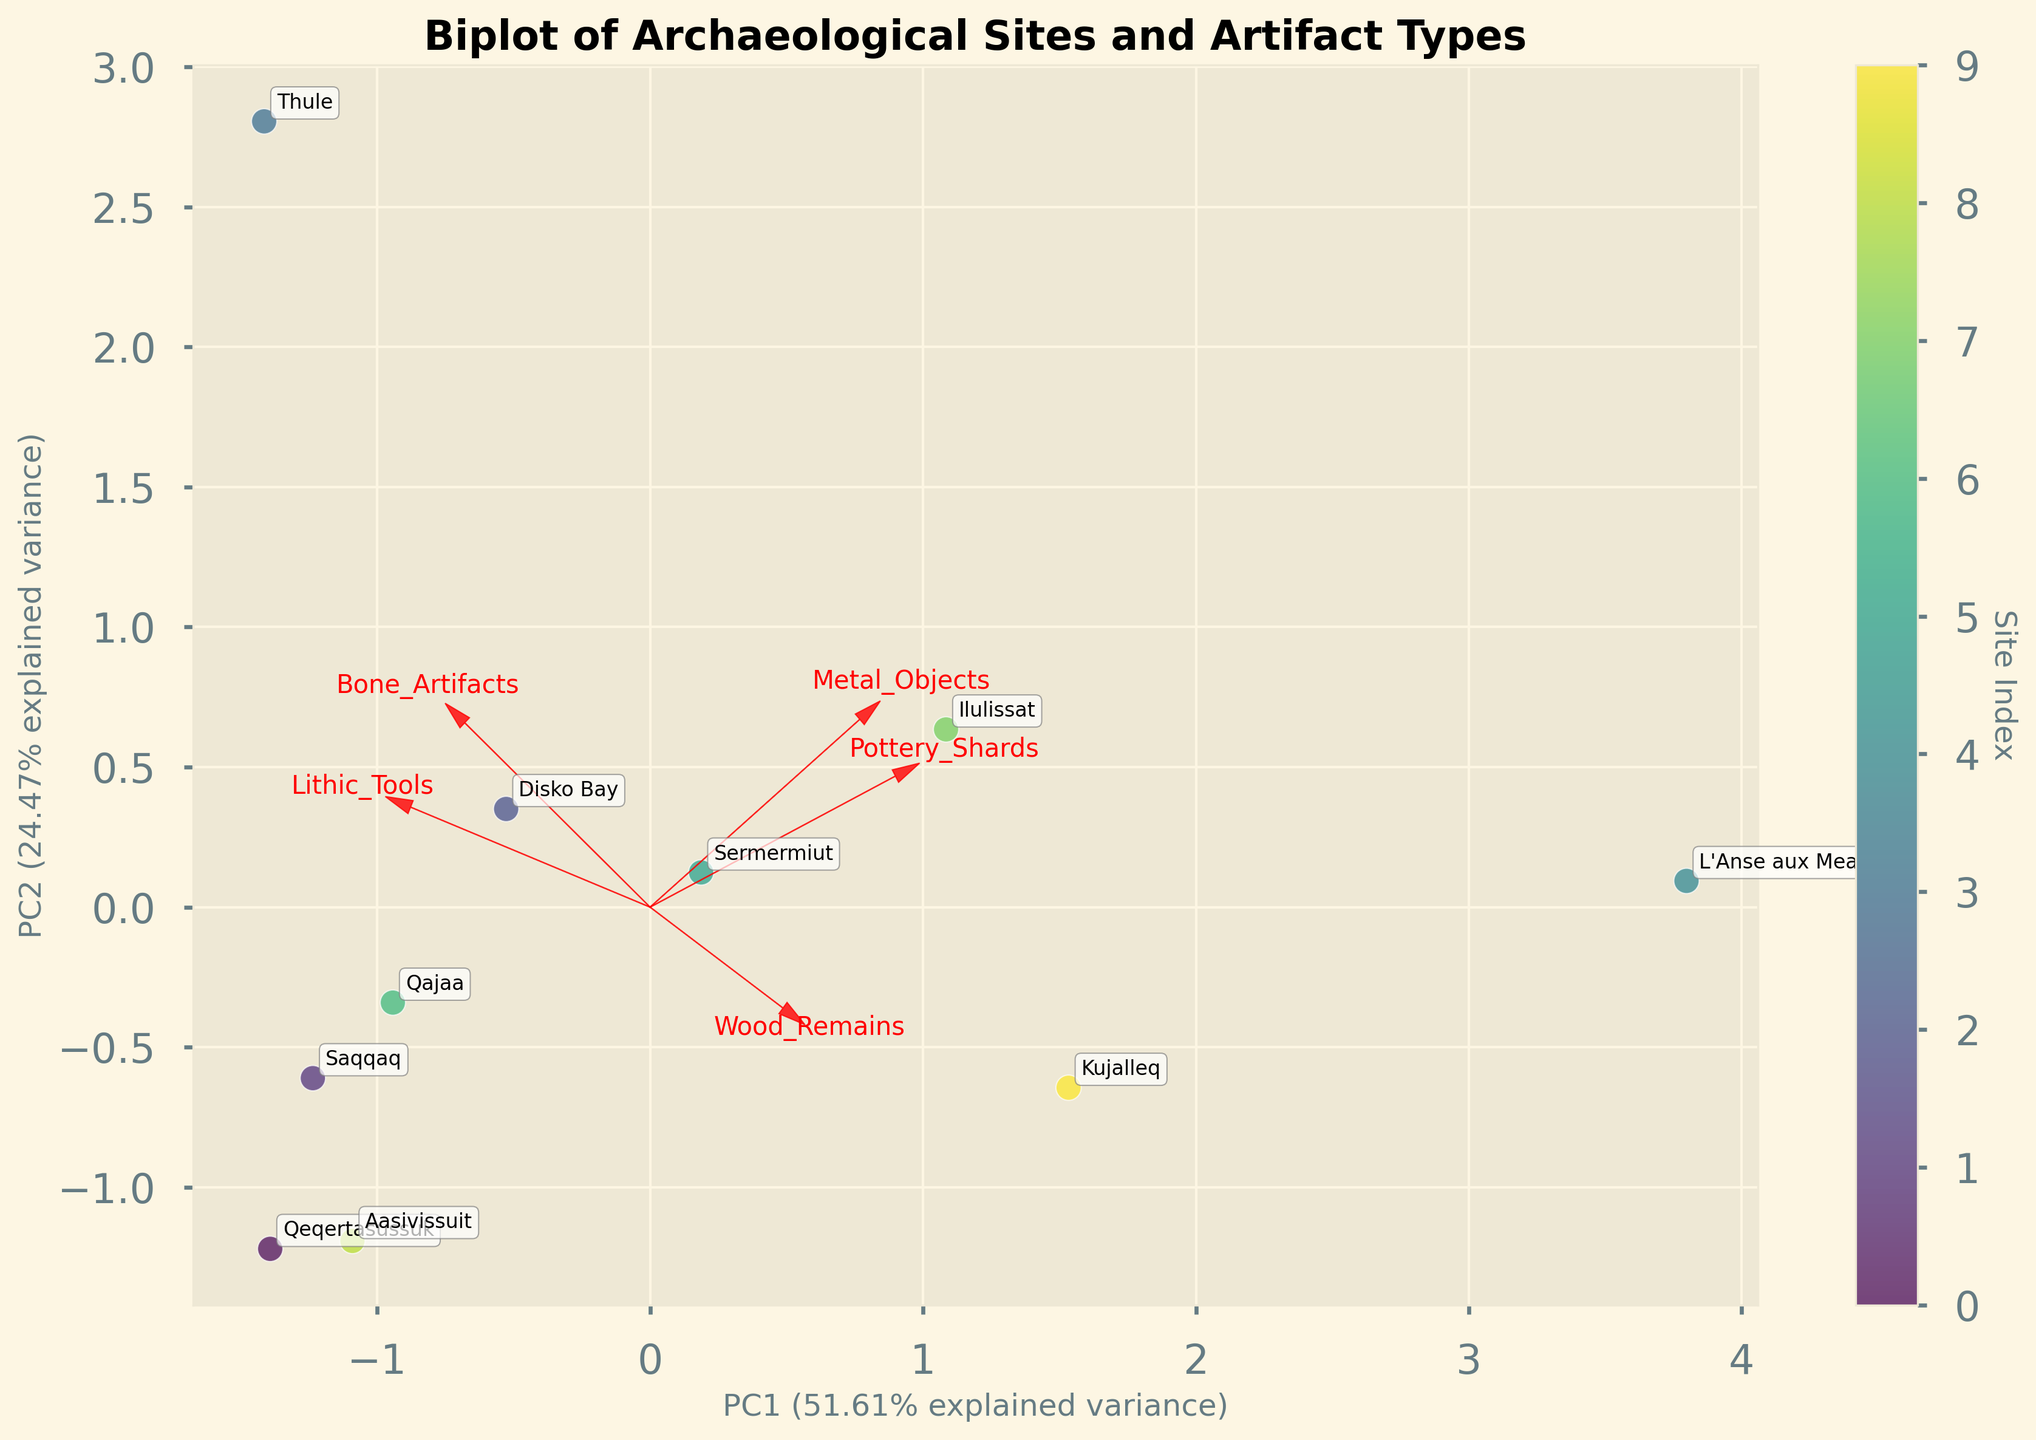What is the title of the figure? The title is usually found at the top of the figure in larger and bolder font to indicate the subject of the plot.
Answer: Biplot of Archaeological Sites and Artifact Types Which site has the highest value on the PC1 axis? To find the site with the highest value on the PC1 axis, look for the data point that is farthest to the right on the horizontal axis.
Answer: Thule How many archaeological sites are represented in the biplot? Count the number of unique labels or annotations in the plot to determine the number of archaeological sites represented.
Answer: 10 Which artifact type has the strongest positive influence on the first principal component (PC1)? Identify the loading vectors (red arrows) and see which artifact type's vector points most strongly in the positive direction of the PC1 axis.
Answer: Bone Artifacts Which two sites appear to be the most similar based on their positions in the biplot? Look for two data points that are closest to each other on the plot, indicating they have similar PC1 and PC2 scores.
Answer: Saqqaq and Qeqertasussuk What is the approximate explained variance of PC1? Check the label of the PC1 axis, which indicates the percentage of the total variance explained by the first principal component.
Answer: Approximately 54% Which artifact types have a negative influence on the second principal component (PC2)? Identify the loading vectors that point downward, indicating a negative influence on the PC2 axis, and then check the labels of these vectors.
Answer: Wood Remains and Metal Objects Which site is positioned furthest in the positive direction along the PC2 axis? Look at the vertical axis (PC2) and find the data point that is highest up, indicating the furthest positive value along this axis.
Answer: L'Anse aux Meadows Considering both PC1 and PC2, which artifact type seems to influence most of the archaeological sites similarly? Look for the loading vector that points toward the majority of the data points, indicating it influences multiple sites similarly.
Answer: Bone Artifacts How do Disko Bay and Qajaa compare in terms of their artifact compositions based on the biplot? Compare their positions relative to the loading vectors on the plot and note any similarities or differences in the direction and magnitude of influence by the artifact types.
Answer: Both are influenced strongly by Bone Artifacts and fall close to each other in the plot 